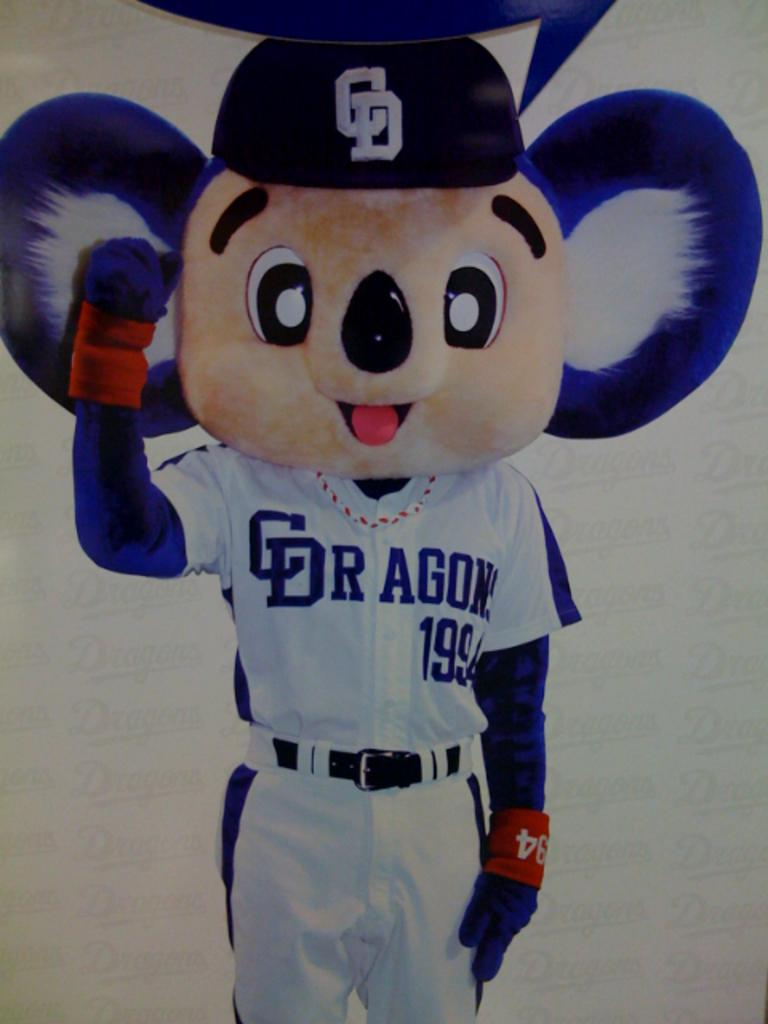Provide a one-sentence caption for the provided image. A shirt that has the wording C dragon 1994 on it. 